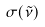Convert formula to latex. <formula><loc_0><loc_0><loc_500><loc_500>\sigma ( \tilde { \nu } )</formula> 